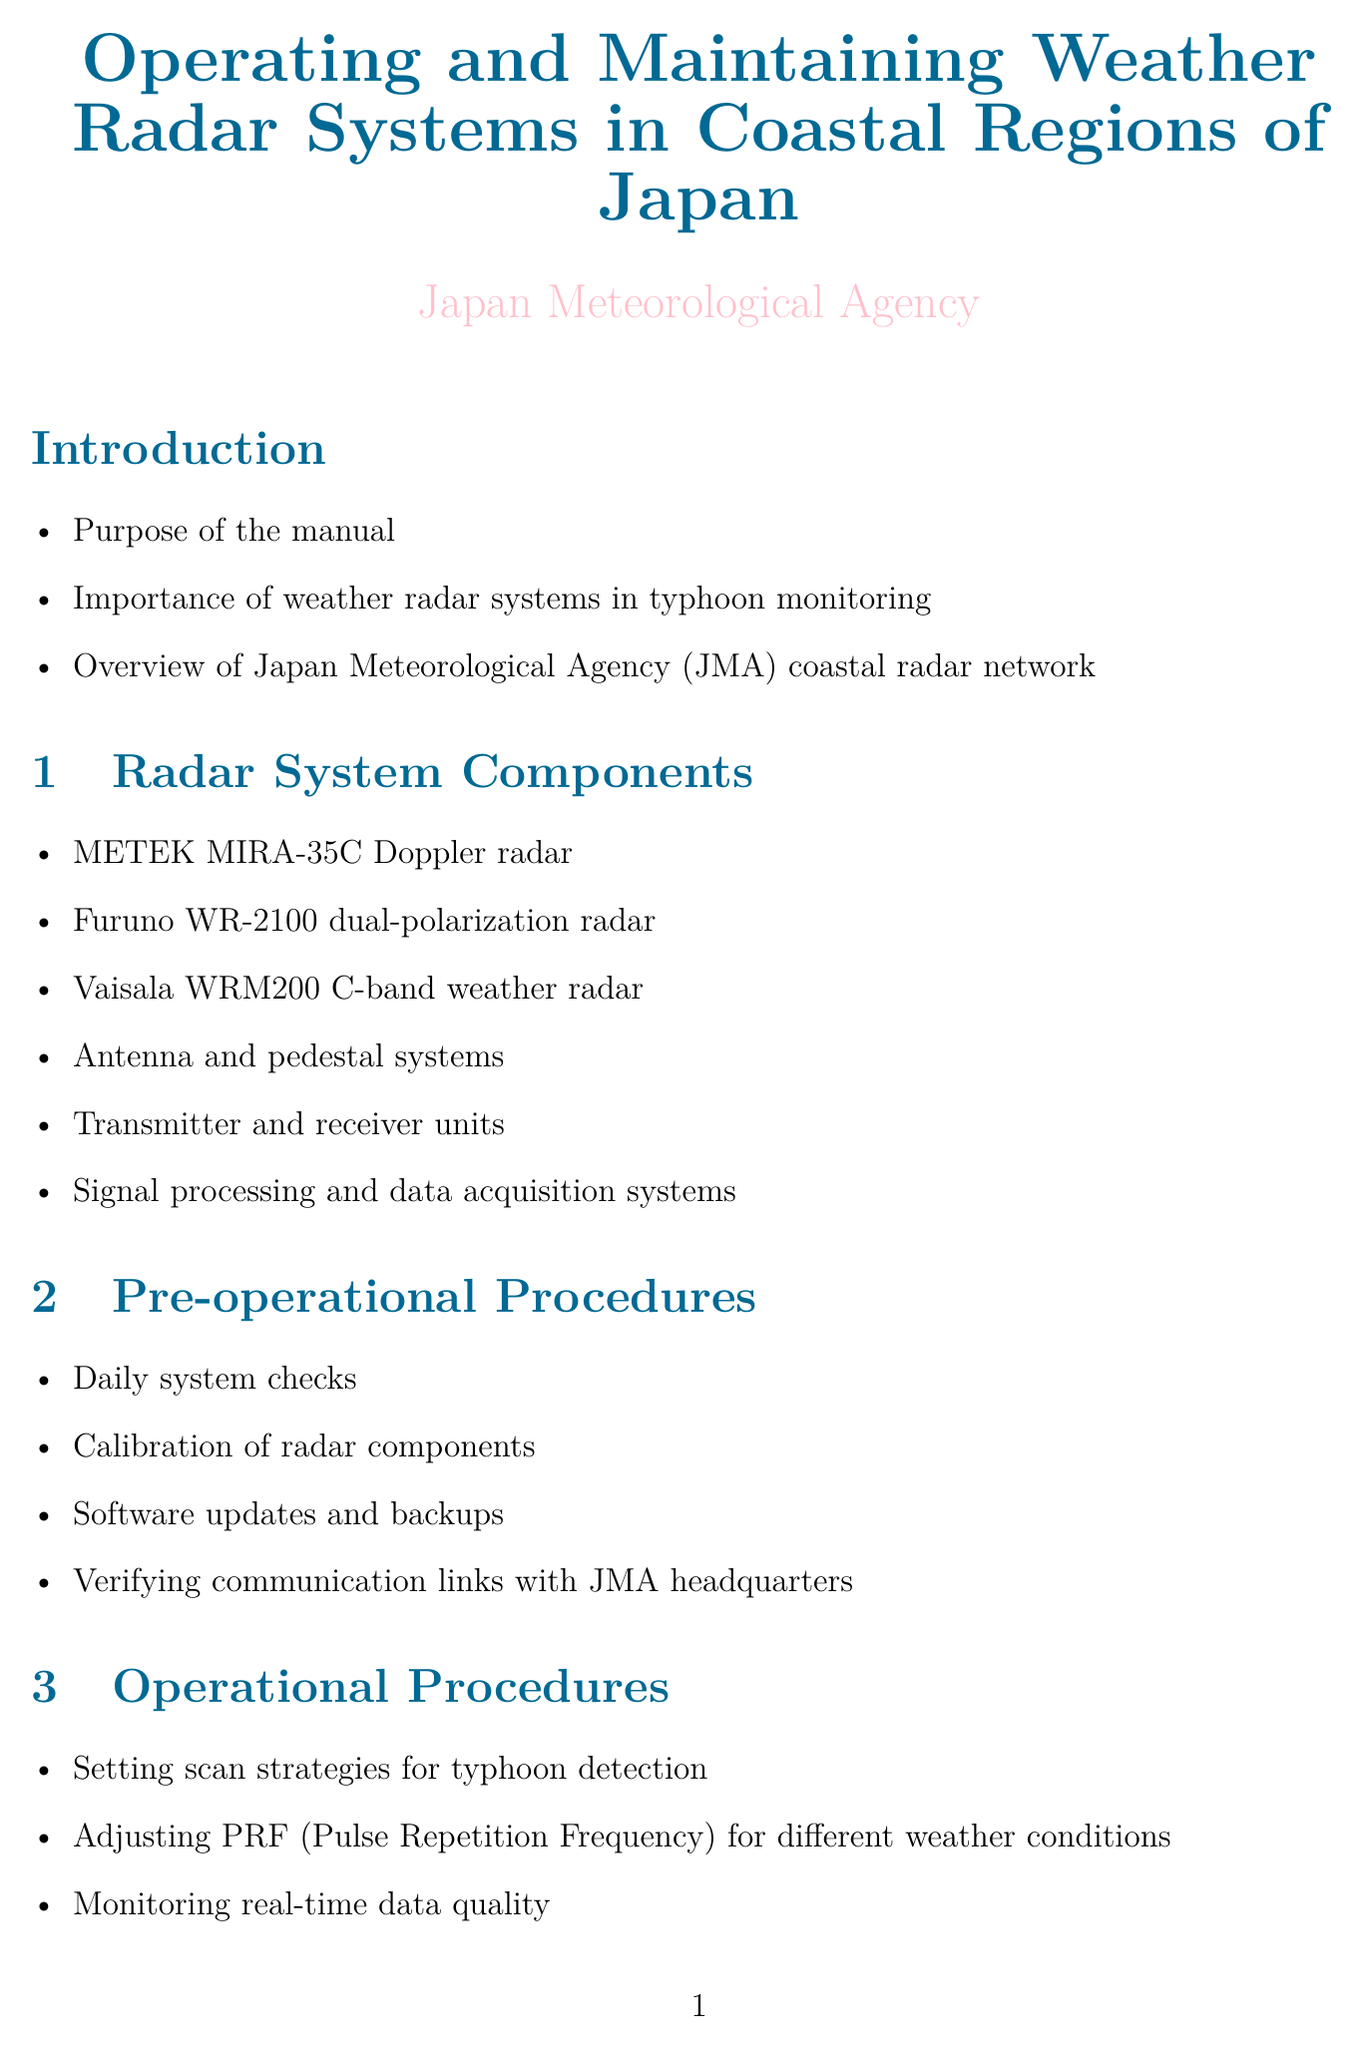What is the purpose of the manual? The purpose is outlined in the Introduction section, specifically focusing on operating and maintaining weather radar systems in coastal regions.
Answer: Purpose of the manual Which radar system is a Doppler type? The METEK MIRA-35C is specified as a Doppler radar in the Radar System Components section.
Answer: METEK MIRA-35C Doppler radar What is the frequency type of the Vaisala WRM200 radar? The radar is identified as a C-band weather radar in the Radar System Components section.
Answer: C-band What does PRF stand for? PRF is defined in the context of adjusting for different weather conditions in the Operational Procedures section.
Answer: Pulse Repetition Frequency Which software is used for data processing? The document specifies the use of IRIS/Sigmet software for data processing in the Data Processing and Analysis section.
Answer: IRIS/Sigmet What maintenance is required for moving parts? The Maintenance Procedures section mentions lubrication of moving parts as a key maintenance task.
Answer: Lubrication What are common issues faced with coastal radar systems? Common issues are highlighted in the Troubleshooting section, listing specific topics to diagnose.
Answer: Common issues with coastal radar systems Which organization does the JMA coordinate with for typhoon tracking? The Okinawa Meteorological Observatory is mentioned for coordination in the Operational Procedures section.
Answer: Okinawa Meteorological Observatory What is one safety measure mentioned in the document? The Safety Protocols section lists radiation safety measures among other protocols for operational safety.
Answer: Radiation safety measures 